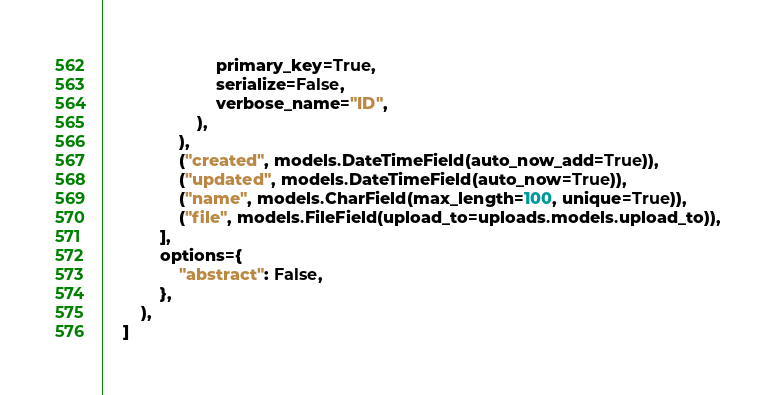<code> <loc_0><loc_0><loc_500><loc_500><_Python_>                        primary_key=True,
                        serialize=False,
                        verbose_name="ID",
                    ),
                ),
                ("created", models.DateTimeField(auto_now_add=True)),
                ("updated", models.DateTimeField(auto_now=True)),
                ("name", models.CharField(max_length=100, unique=True)),
                ("file", models.FileField(upload_to=uploads.models.upload_to)),
            ],
            options={
                "abstract": False,
            },
        ),
    ]
</code> 